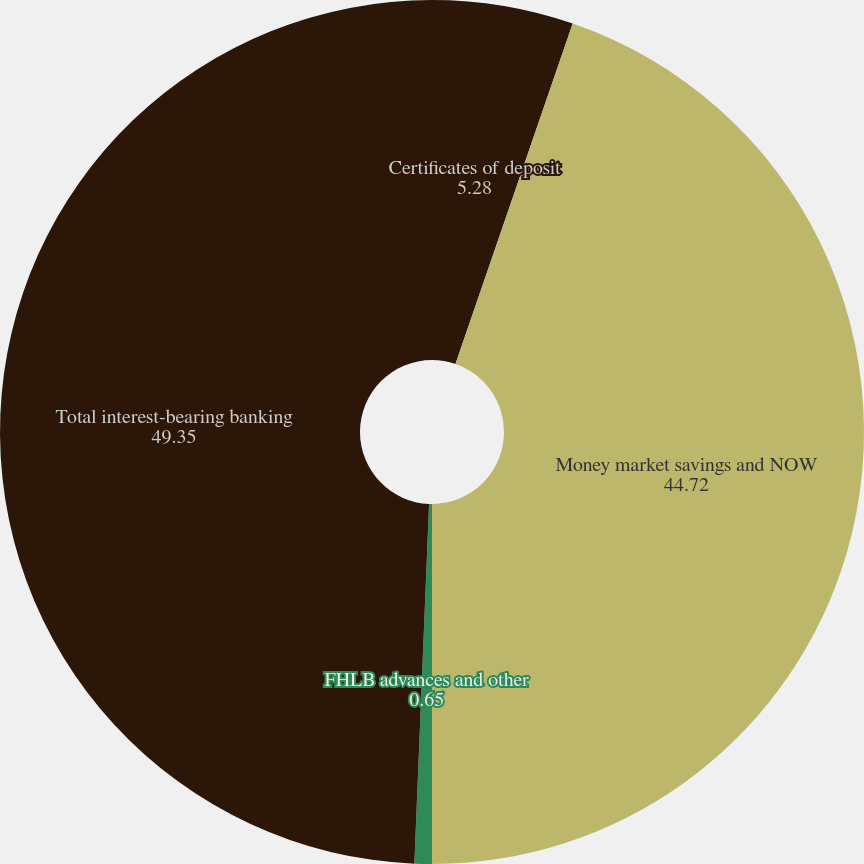<chart> <loc_0><loc_0><loc_500><loc_500><pie_chart><fcel>Certificates of deposit<fcel>Money market savings and NOW<fcel>FHLB advances and other<fcel>Total interest-bearing banking<nl><fcel>5.28%<fcel>44.72%<fcel>0.65%<fcel>49.35%<nl></chart> 